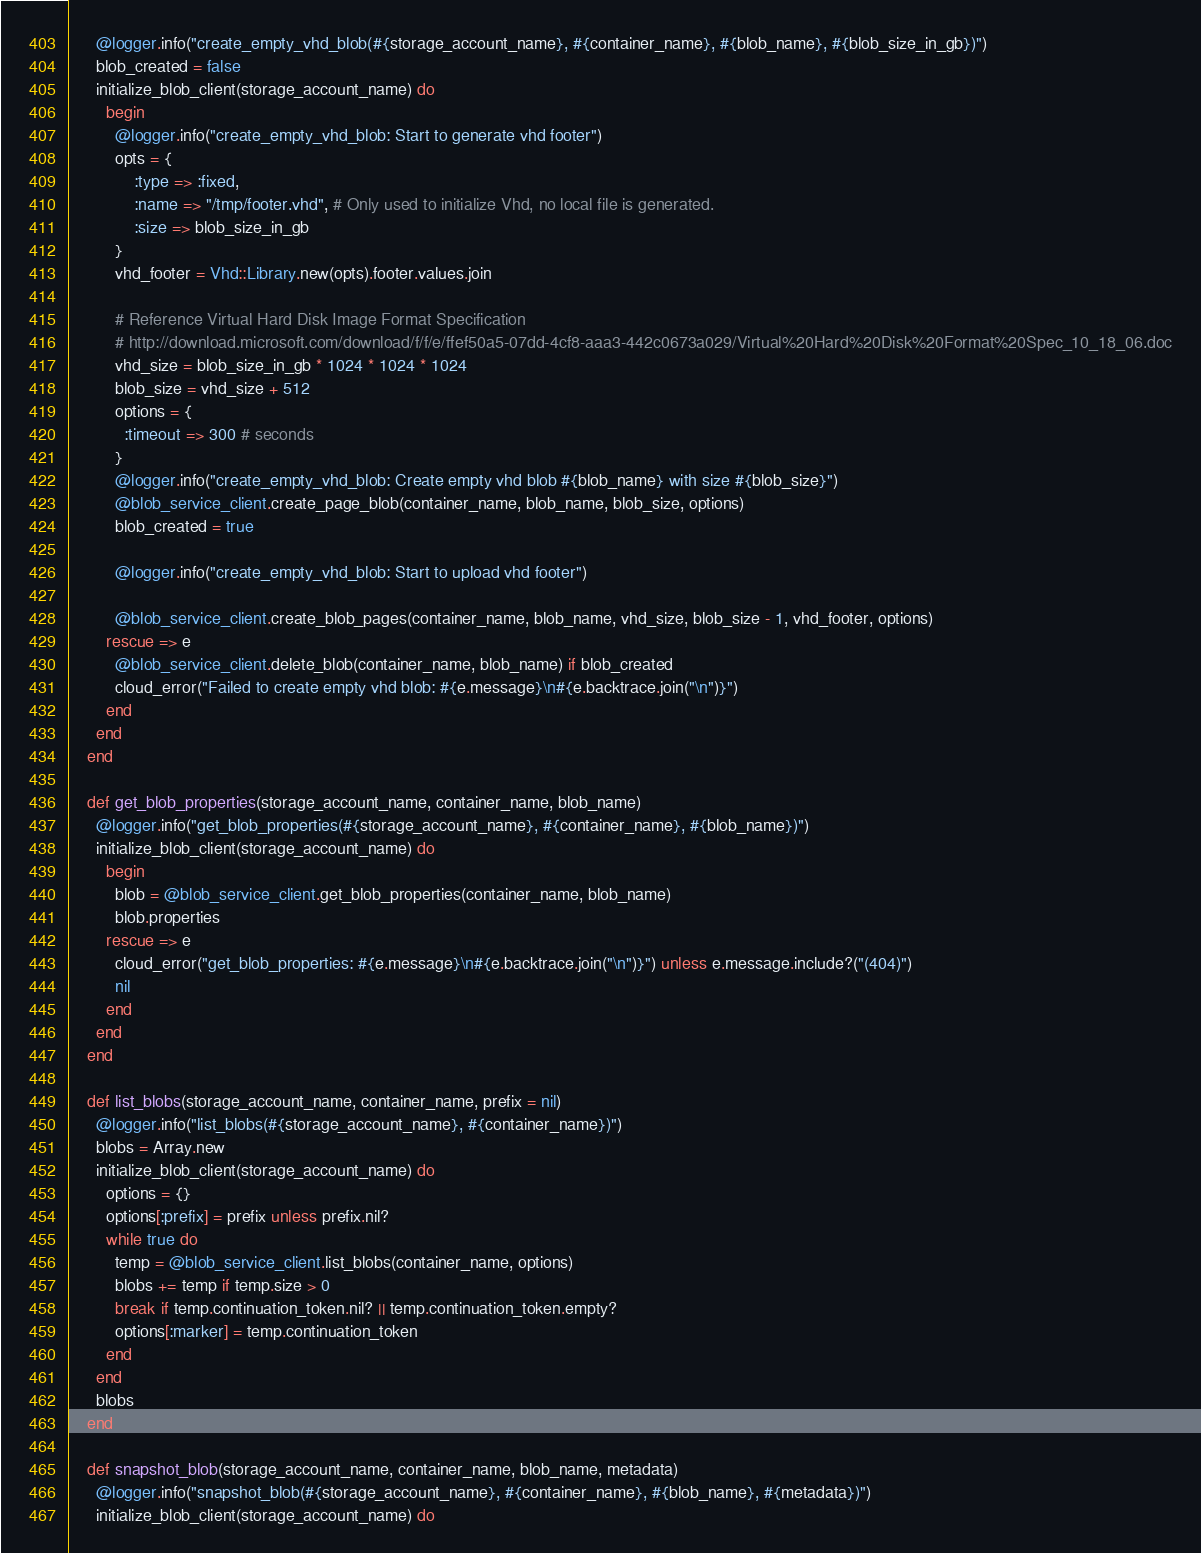Convert code to text. <code><loc_0><loc_0><loc_500><loc_500><_Ruby_>      @logger.info("create_empty_vhd_blob(#{storage_account_name}, #{container_name}, #{blob_name}, #{blob_size_in_gb})")
      blob_created = false
      initialize_blob_client(storage_account_name) do
        begin
          @logger.info("create_empty_vhd_blob: Start to generate vhd footer")
          opts = {
              :type => :fixed,
              :name => "/tmp/footer.vhd", # Only used to initialize Vhd, no local file is generated.
              :size => blob_size_in_gb
          }
          vhd_footer = Vhd::Library.new(opts).footer.values.join

          # Reference Virtual Hard Disk Image Format Specification
          # http://download.microsoft.com/download/f/f/e/ffef50a5-07dd-4cf8-aaa3-442c0673a029/Virtual%20Hard%20Disk%20Format%20Spec_10_18_06.doc
          vhd_size = blob_size_in_gb * 1024 * 1024 * 1024
          blob_size = vhd_size + 512
          options = {
            :timeout => 300 # seconds
          }
          @logger.info("create_empty_vhd_blob: Create empty vhd blob #{blob_name} with size #{blob_size}")
          @blob_service_client.create_page_blob(container_name, blob_name, blob_size, options)
          blob_created = true

          @logger.info("create_empty_vhd_blob: Start to upload vhd footer")

          @blob_service_client.create_blob_pages(container_name, blob_name, vhd_size, blob_size - 1, vhd_footer, options)
        rescue => e
          @blob_service_client.delete_blob(container_name, blob_name) if blob_created
          cloud_error("Failed to create empty vhd blob: #{e.message}\n#{e.backtrace.join("\n")}")
        end
      end
    end

    def get_blob_properties(storage_account_name, container_name, blob_name)
      @logger.info("get_blob_properties(#{storage_account_name}, #{container_name}, #{blob_name})")
      initialize_blob_client(storage_account_name) do
        begin
          blob = @blob_service_client.get_blob_properties(container_name, blob_name)
          blob.properties
        rescue => e
          cloud_error("get_blob_properties: #{e.message}\n#{e.backtrace.join("\n")}") unless e.message.include?("(404)")
          nil
        end
      end
    end

    def list_blobs(storage_account_name, container_name, prefix = nil)
      @logger.info("list_blobs(#{storage_account_name}, #{container_name})")
      blobs = Array.new
      initialize_blob_client(storage_account_name) do
        options = {}
        options[:prefix] = prefix unless prefix.nil?
        while true do
          temp = @blob_service_client.list_blobs(container_name, options)
          blobs += temp if temp.size > 0
          break if temp.continuation_token.nil? || temp.continuation_token.empty?
          options[:marker] = temp.continuation_token
        end
      end
      blobs
    end

    def snapshot_blob(storage_account_name, container_name, blob_name, metadata)
      @logger.info("snapshot_blob(#{storage_account_name}, #{container_name}, #{blob_name}, #{metadata})")
      initialize_blob_client(storage_account_name) do</code> 